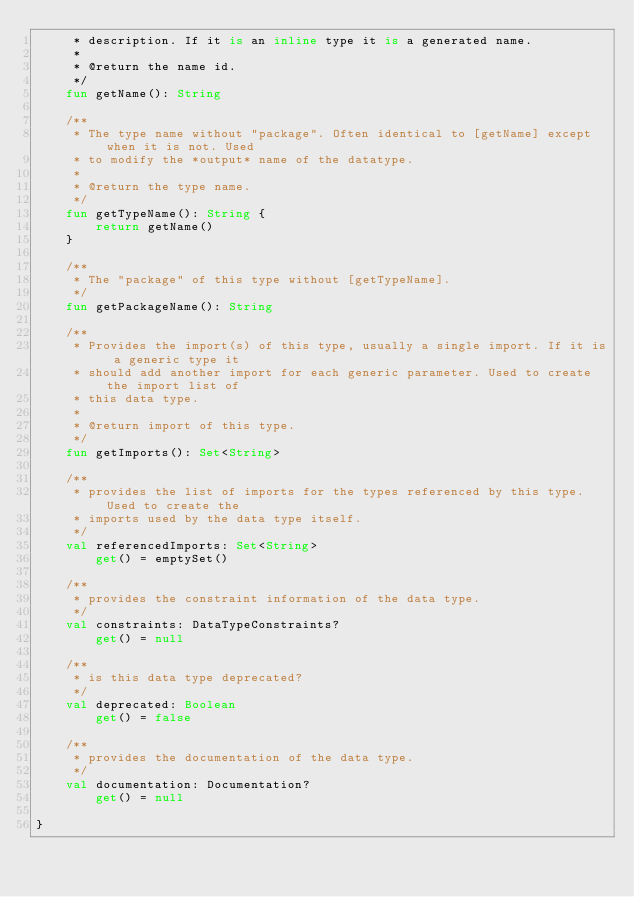<code> <loc_0><loc_0><loc_500><loc_500><_Kotlin_>     * description. If it is an inline type it is a generated name.
     *
     * @return the name id.
     */
    fun getName(): String

    /**
     * The type name without "package". Often identical to [getName] except when it is not. Used
     * to modify the *output* name of the datatype.
     *
     * @return the type name.
     */
    fun getTypeName(): String {
        return getName()
    }

    /**
     * The "package" of this type without [getTypeName].
     */
    fun getPackageName(): String

    /**
     * Provides the import(s) of this type, usually a single import. If it is a generic type it
     * should add another import for each generic parameter. Used to create the import list of
     * this data type.
     *
     * @return import of this type.
     */
    fun getImports(): Set<String>

    /**
     * provides the list of imports for the types referenced by this type. Used to create the
     * imports used by the data type itself.
     */
    val referencedImports: Set<String>
        get() = emptySet()

    /**
     * provides the constraint information of the data type.
     */
    val constraints: DataTypeConstraints?
        get() = null

    /**
     * is this data type deprecated?
     */
    val deprecated: Boolean
        get() = false

    /**
     * provides the documentation of the data type.
     */
    val documentation: Documentation?
        get() = null

}
</code> 